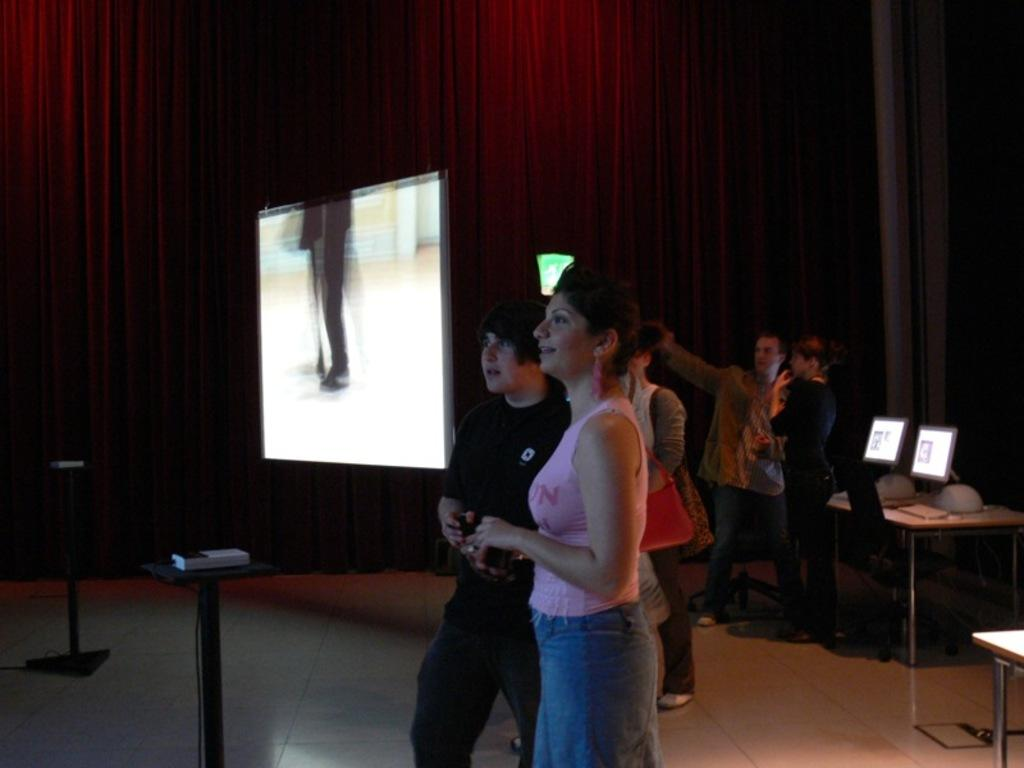What are the people in the image doing? There is a group of standing people in the image. What objects are on the table in the image? There are monitors and keyboards on the table in the image. What is the large screen in the image used for? There is a projector screen in the image, which is likely used for presentations or displays. What type of window treatment is present in the image? There are curtains in the image. What type of yarn is being used to create the comparison between the two monitors in the image? There is no yarn present in the image, nor is there any comparison being made between the monitors. 